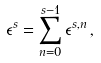Convert formula to latex. <formula><loc_0><loc_0><loc_500><loc_500>\epsilon ^ { s } = \sum _ { n = 0 } ^ { s - 1 } \epsilon ^ { s , n } \, ,</formula> 